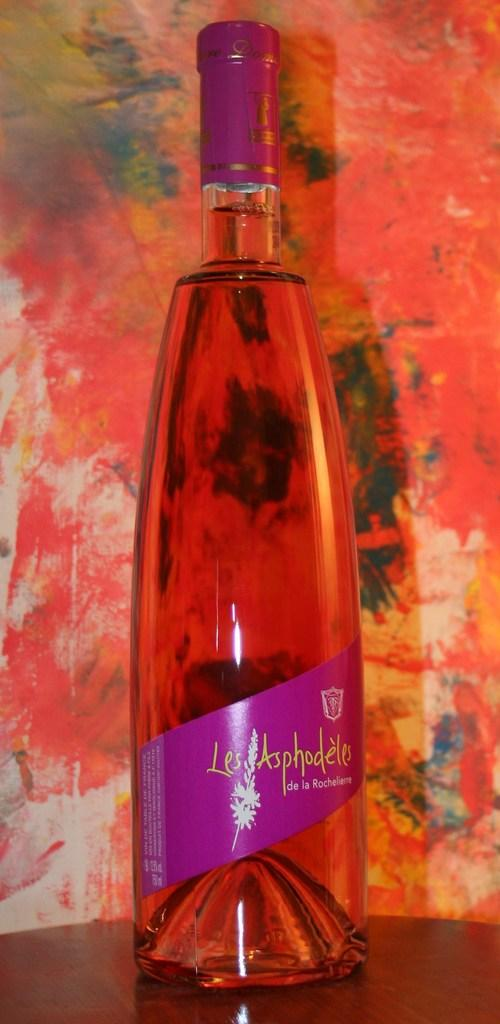What object can be seen in the image? There is a bottle in the image. What can be seen in the background of the image? There is a painting in the background of the image. What type of zebra is depicted in the painting in the image? There is no zebra present in the image, as the painting in the background is not described in detail. 